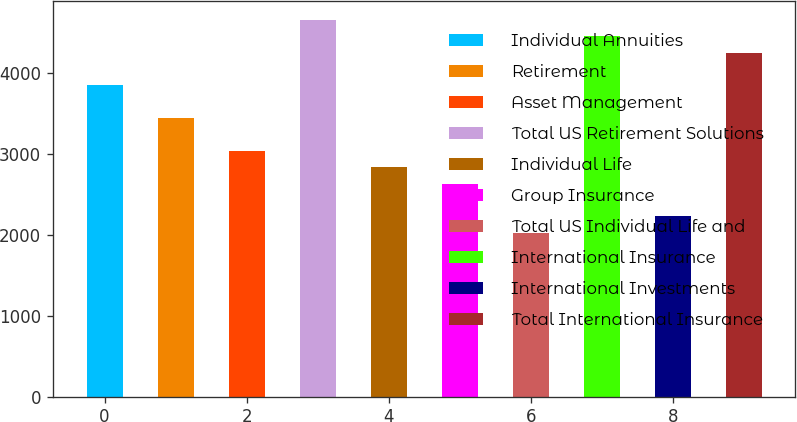<chart> <loc_0><loc_0><loc_500><loc_500><bar_chart><fcel>Individual Annuities<fcel>Retirement<fcel>Asset Management<fcel>Total US Retirement Solutions<fcel>Individual Life<fcel>Group Insurance<fcel>Total US Individual Life and<fcel>International Insurance<fcel>International Investments<fcel>Total International Insurance<nl><fcel>3849.08<fcel>3444.18<fcel>3039.28<fcel>4658.88<fcel>2836.83<fcel>2634.38<fcel>2027.03<fcel>4456.43<fcel>2229.48<fcel>4253.98<nl></chart> 